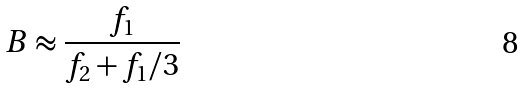<formula> <loc_0><loc_0><loc_500><loc_500>B \approx \frac { f _ { 1 } } { f _ { 2 } + f _ { 1 } / 3 }</formula> 